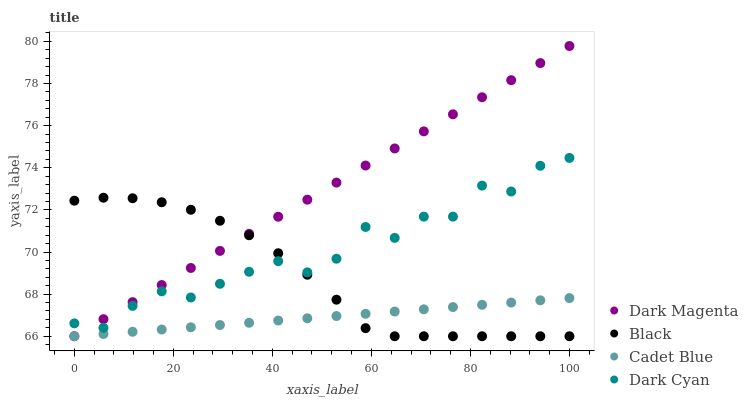Does Cadet Blue have the minimum area under the curve?
Answer yes or no. Yes. Does Dark Magenta have the maximum area under the curve?
Answer yes or no. Yes. Does Black have the minimum area under the curve?
Answer yes or no. No. Does Black have the maximum area under the curve?
Answer yes or no. No. Is Cadet Blue the smoothest?
Answer yes or no. Yes. Is Dark Cyan the roughest?
Answer yes or no. Yes. Is Black the smoothest?
Answer yes or no. No. Is Black the roughest?
Answer yes or no. No. Does Cadet Blue have the lowest value?
Answer yes or no. Yes. Does Dark Magenta have the highest value?
Answer yes or no. Yes. Does Black have the highest value?
Answer yes or no. No. Is Cadet Blue less than Dark Cyan?
Answer yes or no. Yes. Is Dark Cyan greater than Cadet Blue?
Answer yes or no. Yes. Does Cadet Blue intersect Dark Magenta?
Answer yes or no. Yes. Is Cadet Blue less than Dark Magenta?
Answer yes or no. No. Is Cadet Blue greater than Dark Magenta?
Answer yes or no. No. Does Cadet Blue intersect Dark Cyan?
Answer yes or no. No. 